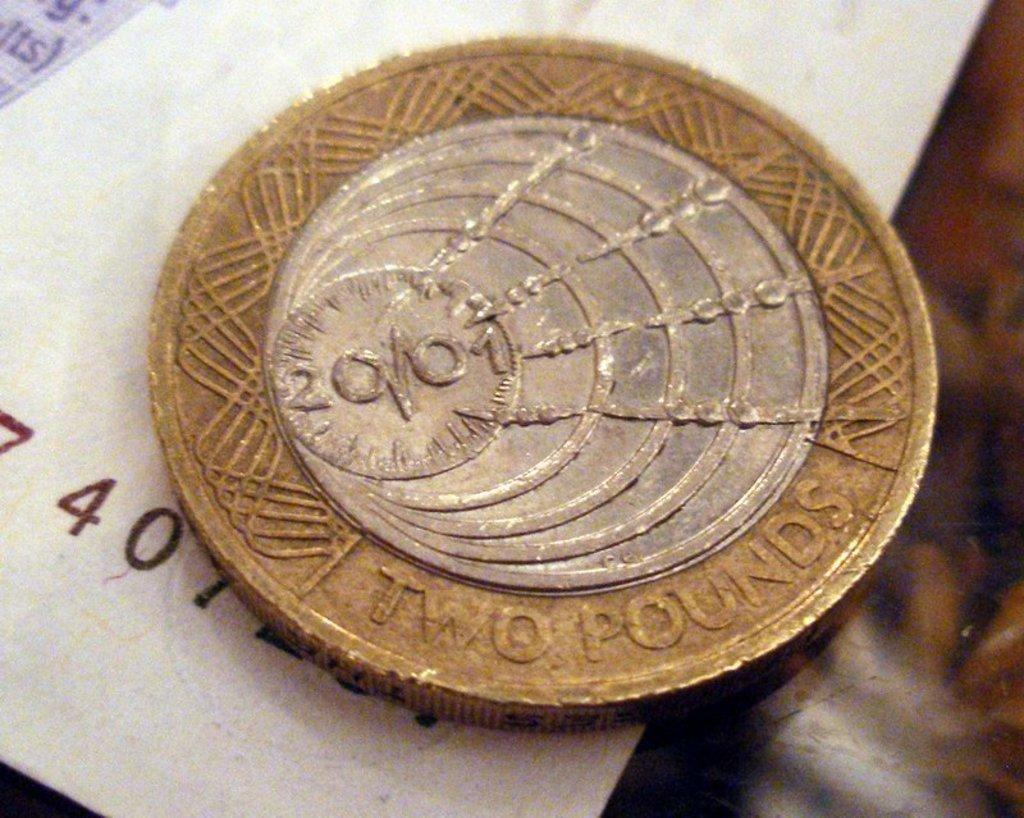What is one of the objects in the image? There is a coin in the image. What is the other object in the image? There is a white object in the image. Where are the objects located in the image? Both objects are on a surface. How many geese are present in the image? There are no geese present in the image. What type of parent is depicted in the image? There is no parent depicted in the image. 